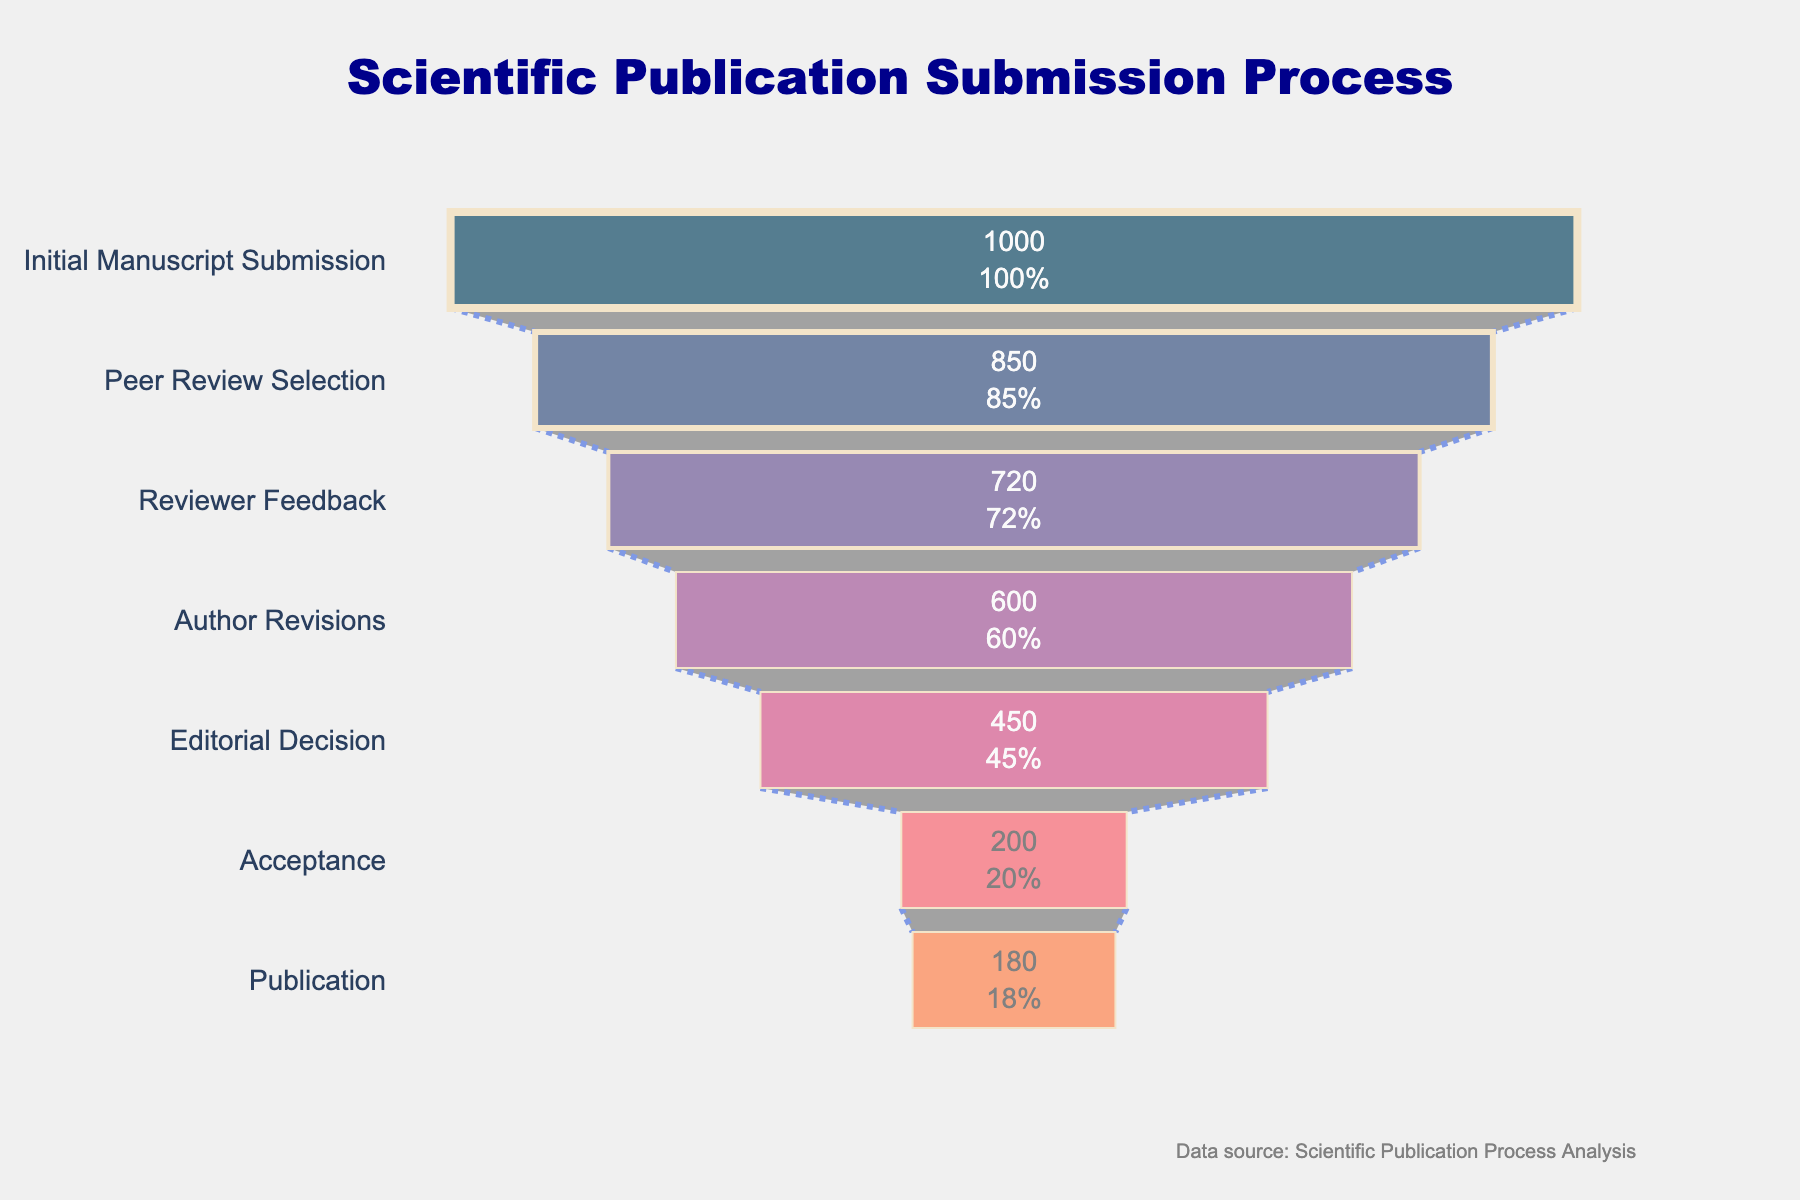What is the total number of initial manuscript submissions? The funnel chart shows the number of submissions at each stage of the scientific publication submission process. The first stage, labeled "Initial Manuscript Submission," has a total of 1000 submissions.
Answer: 1000 What percentage of submissions make it from the initial manuscript submission to publication? To find the percentage, divide the number of publications by the initial manuscript submissions and multiply by 100. There are 180 publications out of 1000 initial submissions. Calculation: (180 / 1000) * 100 = 18%.
Answer: 18% Which stage shows the greatest drop in submissions? Comparing the drop in submissions between each sequential stage, the largest decrease occurs between "Editorial Decision" (450) and "Acceptance" (200), which represents a drop of 250 submissions.
Answer: Between Editorial Decision and Acceptance What is the proportion of submissions that receive reviewer feedback after peer review selection? Divide the number of submissions that receive reviewer feedback (720) by the number of submissions that go through peer review selection (850), then multiply by 100 to get the percentage. Calculation: (720 / 850) * 100 ≈ 84.71%.
Answer: Approximately 84.71% How many submissions are made between the Initial Manuscript Submission and Peer Review Selection stages? Subtract the number of submissions at the Peer Review Selection stage (850) from the Initial Manuscript Submission stage (1000). Calculation: 1000 - 850 = 150.
Answer: 150 What is the difference between the number of submissions at the Editorial Decision and Publication stages? Subtract the number of publications (180) from the number of submissions at the Editorial Decision stage (450). Calculation: 450 - 180 = 270.
Answer: 270 Between which stages does the acceptance rate drop by more than 50%? To identify the stages, compare the acceptance rate percentage drop stage by stage. The significant drop greater than 50% happens between "Editorial Decision" (450 submissions) and "Acceptance" (200 submissions). Calculation: (450 - 200) / 450 * 100 ≈ 55.56%.
Answer: Between Editorial Decision and Acceptance What is the title of the funnel chart? The chart's title is prominently displayed at the top. It reads, "Scientific Publication Submission Process."
Answer: Scientific Publication Submission Process How many stages are represented in the funnel chart? Counting the number of labels on the funnel chart reveals there are seven stages: "Initial Manuscript Submission," "Peer Review Selection," "Reviewer Feedback," "Author Revisions," "Editorial Decision," "Acceptance," and "Publication."
Answer: 7 stages 